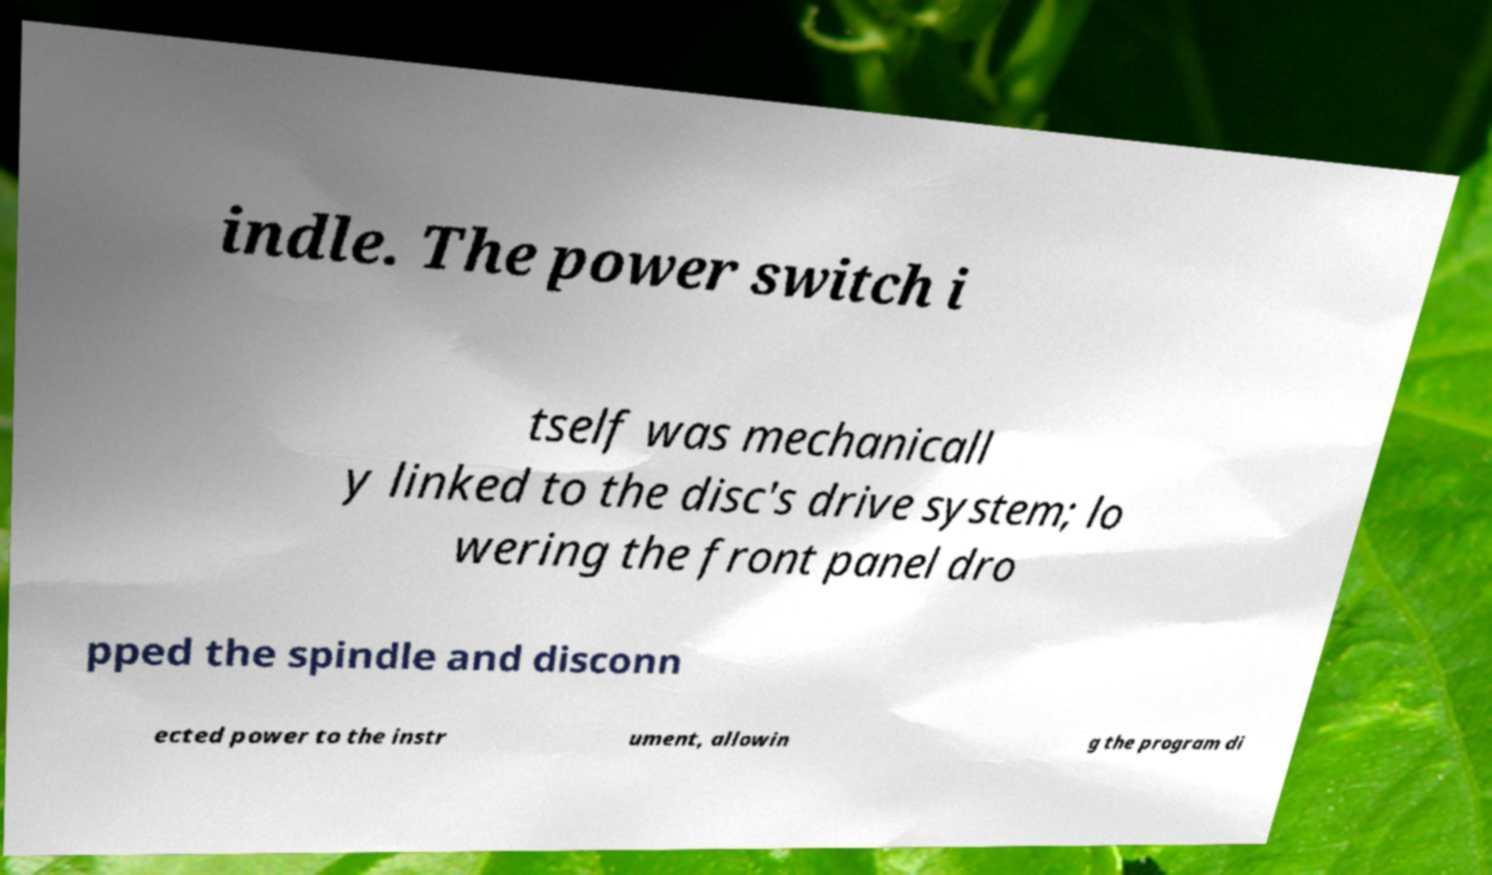For documentation purposes, I need the text within this image transcribed. Could you provide that? indle. The power switch i tself was mechanicall y linked to the disc's drive system; lo wering the front panel dro pped the spindle and disconn ected power to the instr ument, allowin g the program di 